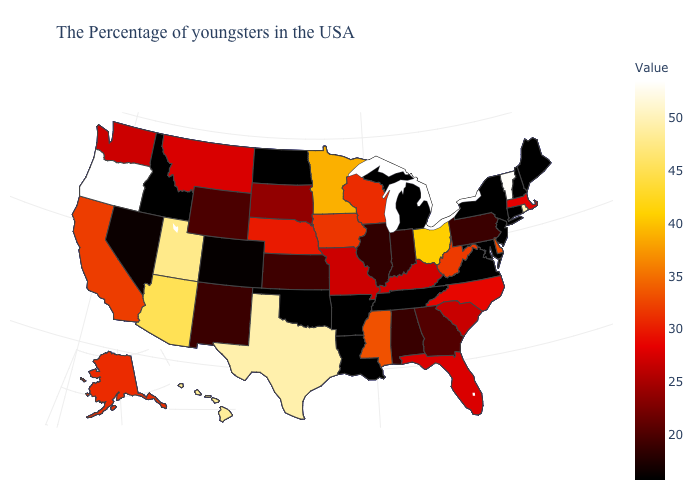Which states hav the highest value in the Northeast?
Short answer required. Vermont. Does Indiana have the highest value in the MidWest?
Be succinct. No. Among the states that border Nevada , does Oregon have the highest value?
Give a very brief answer. Yes. Does Colorado have a lower value than Iowa?
Give a very brief answer. Yes. Does Oregon have the highest value in the West?
Be succinct. Yes. 